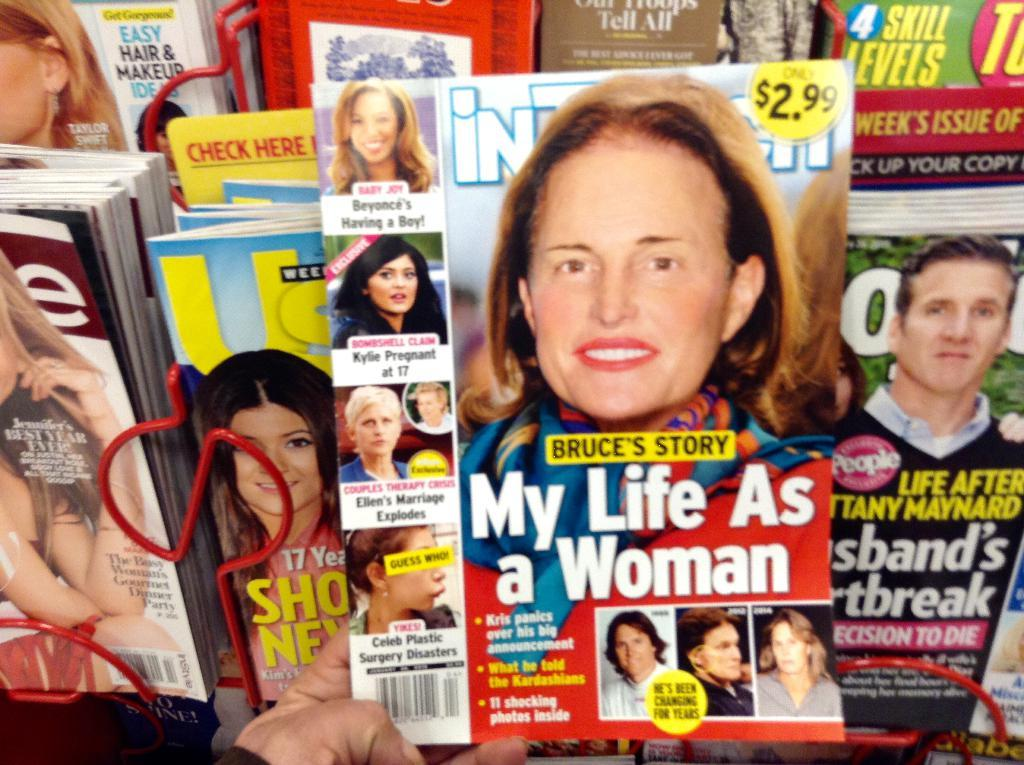What objects are present in large quantities in the image? There are a lot of magazines in the image. Can you describe the person in the image? There is a person in the image. What is the person holding in their hand? The person is holding a magazine with their hand. What type of airplane is visible in the image? There is no airplane present in the image. How does the person sneeze while holding the magazine in the image? There is no indication in the image that the person is sneezing while holding the magazine. 